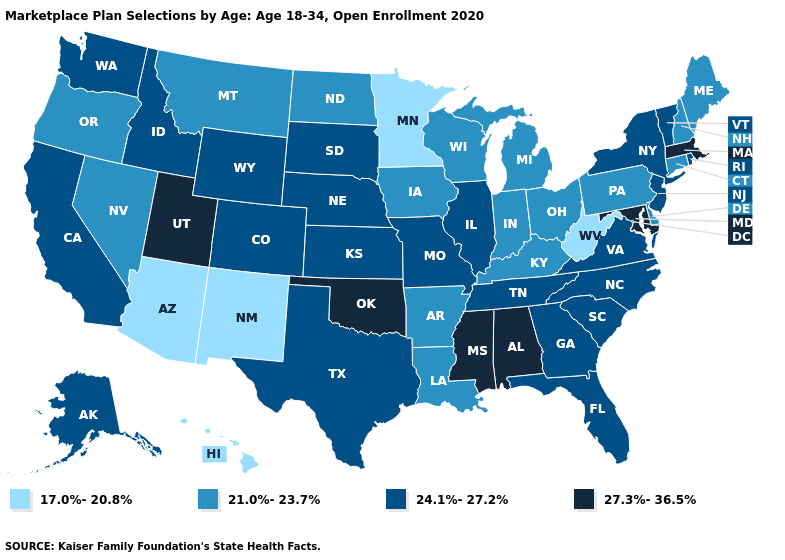Which states hav the highest value in the South?
Short answer required. Alabama, Maryland, Mississippi, Oklahoma. Does the first symbol in the legend represent the smallest category?
Keep it brief. Yes. What is the highest value in the Northeast ?
Quick response, please. 27.3%-36.5%. What is the highest value in states that border Nebraska?
Quick response, please. 24.1%-27.2%. What is the lowest value in the MidWest?
Quick response, please. 17.0%-20.8%. What is the value of Minnesota?
Give a very brief answer. 17.0%-20.8%. Does Connecticut have a lower value than South Dakota?
Concise answer only. Yes. Name the states that have a value in the range 17.0%-20.8%?
Answer briefly. Arizona, Hawaii, Minnesota, New Mexico, West Virginia. How many symbols are there in the legend?
Quick response, please. 4. Does Montana have the highest value in the USA?
Be succinct. No. Name the states that have a value in the range 27.3%-36.5%?
Give a very brief answer. Alabama, Maryland, Massachusetts, Mississippi, Oklahoma, Utah. What is the value of Tennessee?
Concise answer only. 24.1%-27.2%. What is the highest value in the USA?
Quick response, please. 27.3%-36.5%. Which states hav the highest value in the West?
Quick response, please. Utah. What is the highest value in states that border Montana?
Concise answer only. 24.1%-27.2%. 